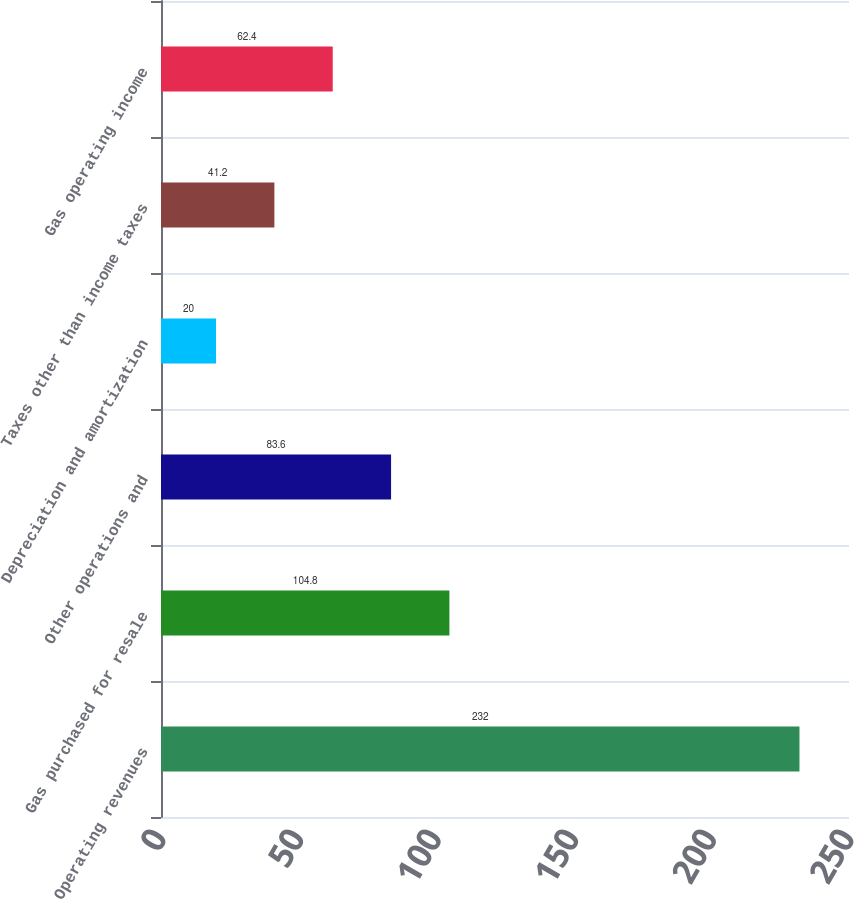<chart> <loc_0><loc_0><loc_500><loc_500><bar_chart><fcel>Operating revenues<fcel>Gas purchased for resale<fcel>Other operations and<fcel>Depreciation and amortization<fcel>Taxes other than income taxes<fcel>Gas operating income<nl><fcel>232<fcel>104.8<fcel>83.6<fcel>20<fcel>41.2<fcel>62.4<nl></chart> 